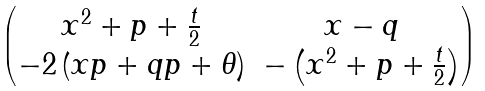Convert formula to latex. <formula><loc_0><loc_0><loc_500><loc_500>\begin{pmatrix} x ^ { 2 } + p + \frac { t } { 2 } & x - q \\ - 2 \left ( x p + q p + \theta \right ) & - \left ( x ^ { 2 } + p + \frac { t } { 2 } \right ) \end{pmatrix}</formula> 